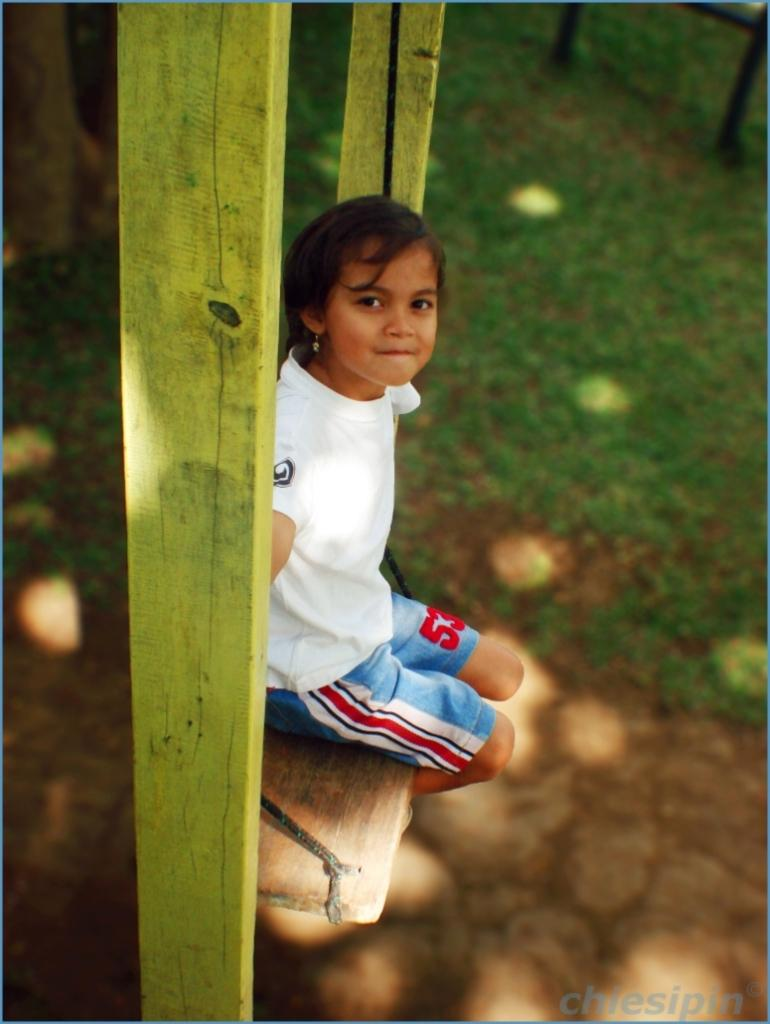Provide a one-sentence caption for the provided image. A young girl numbered 53 sits on a wooden swing. 